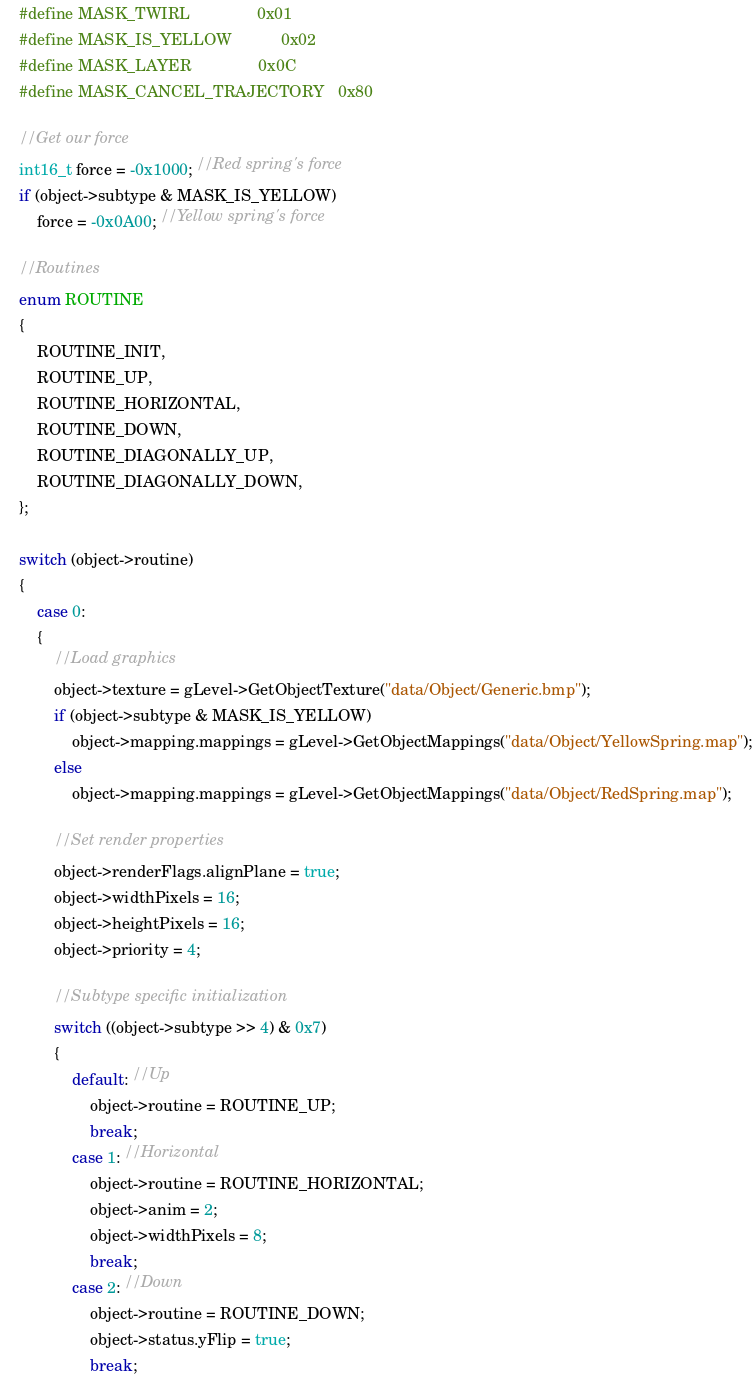Convert code to text. <code><loc_0><loc_0><loc_500><loc_500><_C++_>	#define MASK_TWIRL				0x01
	#define MASK_IS_YELLOW			0x02
	#define MASK_LAYER				0x0C
	#define MASK_CANCEL_TRAJECTORY	0x80
	
	//Get our force
	int16_t force = -0x1000; //Red spring's force
	if (object->subtype & MASK_IS_YELLOW)
		force = -0x0A00; //Yellow spring's force
	
	//Routines
	enum ROUTINE
	{
		ROUTINE_INIT,
		ROUTINE_UP,
		ROUTINE_HORIZONTAL,
		ROUTINE_DOWN,
		ROUTINE_DIAGONALLY_UP,
		ROUTINE_DIAGONALLY_DOWN,
	};
	
	switch (object->routine)
	{
		case 0:
		{
			//Load graphics
			object->texture = gLevel->GetObjectTexture("data/Object/Generic.bmp");
			if (object->subtype & MASK_IS_YELLOW)
				object->mapping.mappings = gLevel->GetObjectMappings("data/Object/YellowSpring.map");
			else
				object->mapping.mappings = gLevel->GetObjectMappings("data/Object/RedSpring.map");
			
			//Set render properties
			object->renderFlags.alignPlane = true;
			object->widthPixels = 16;
			object->heightPixels = 16;
			object->priority = 4;
			
			//Subtype specific initialization
			switch ((object->subtype >> 4) & 0x7)
			{
				default: //Up
					object->routine = ROUTINE_UP;
					break;
				case 1: //Horizontal
					object->routine = ROUTINE_HORIZONTAL;
					object->anim = 2;
					object->widthPixels = 8;
					break;
				case 2: //Down
					object->routine = ROUTINE_DOWN;
					object->status.yFlip = true;
					break;</code> 